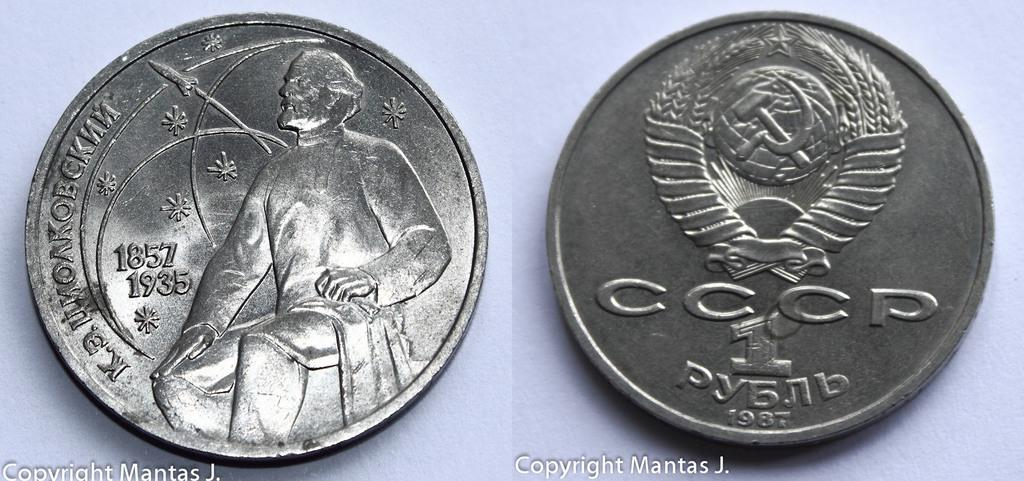Provide a one-sentence caption for the provided image. The coin on the right shown was made in 1987. 